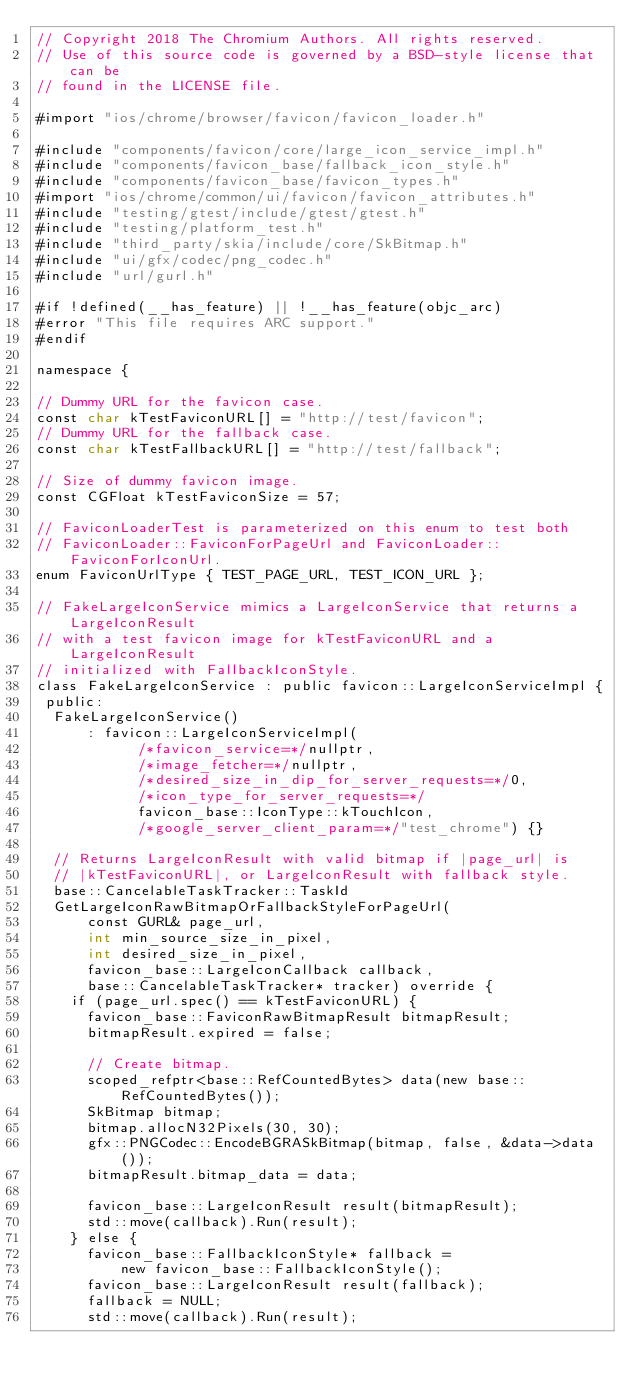<code> <loc_0><loc_0><loc_500><loc_500><_ObjectiveC_>// Copyright 2018 The Chromium Authors. All rights reserved.
// Use of this source code is governed by a BSD-style license that can be
// found in the LICENSE file.

#import "ios/chrome/browser/favicon/favicon_loader.h"

#include "components/favicon/core/large_icon_service_impl.h"
#include "components/favicon_base/fallback_icon_style.h"
#include "components/favicon_base/favicon_types.h"
#import "ios/chrome/common/ui/favicon/favicon_attributes.h"
#include "testing/gtest/include/gtest/gtest.h"
#include "testing/platform_test.h"
#include "third_party/skia/include/core/SkBitmap.h"
#include "ui/gfx/codec/png_codec.h"
#include "url/gurl.h"

#if !defined(__has_feature) || !__has_feature(objc_arc)
#error "This file requires ARC support."
#endif

namespace {

// Dummy URL for the favicon case.
const char kTestFaviconURL[] = "http://test/favicon";
// Dummy URL for the fallback case.
const char kTestFallbackURL[] = "http://test/fallback";

// Size of dummy favicon image.
const CGFloat kTestFaviconSize = 57;

// FaviconLoaderTest is parameterized on this enum to test both
// FaviconLoader::FaviconForPageUrl and FaviconLoader::FaviconForIconUrl.
enum FaviconUrlType { TEST_PAGE_URL, TEST_ICON_URL };

// FakeLargeIconService mimics a LargeIconService that returns a LargeIconResult
// with a test favicon image for kTestFaviconURL and a LargeIconResult
// initialized with FallbackIconStyle.
class FakeLargeIconService : public favicon::LargeIconServiceImpl {
 public:
  FakeLargeIconService()
      : favicon::LargeIconServiceImpl(
            /*favicon_service=*/nullptr,
            /*image_fetcher=*/nullptr,
            /*desired_size_in_dip_for_server_requests=*/0,
            /*icon_type_for_server_requests=*/
            favicon_base::IconType::kTouchIcon,
            /*google_server_client_param=*/"test_chrome") {}

  // Returns LargeIconResult with valid bitmap if |page_url| is
  // |kTestFaviconURL|, or LargeIconResult with fallback style.
  base::CancelableTaskTracker::TaskId
  GetLargeIconRawBitmapOrFallbackStyleForPageUrl(
      const GURL& page_url,
      int min_source_size_in_pixel,
      int desired_size_in_pixel,
      favicon_base::LargeIconCallback callback,
      base::CancelableTaskTracker* tracker) override {
    if (page_url.spec() == kTestFaviconURL) {
      favicon_base::FaviconRawBitmapResult bitmapResult;
      bitmapResult.expired = false;

      // Create bitmap.
      scoped_refptr<base::RefCountedBytes> data(new base::RefCountedBytes());
      SkBitmap bitmap;
      bitmap.allocN32Pixels(30, 30);
      gfx::PNGCodec::EncodeBGRASkBitmap(bitmap, false, &data->data());
      bitmapResult.bitmap_data = data;

      favicon_base::LargeIconResult result(bitmapResult);
      std::move(callback).Run(result);
    } else {
      favicon_base::FallbackIconStyle* fallback =
          new favicon_base::FallbackIconStyle();
      favicon_base::LargeIconResult result(fallback);
      fallback = NULL;
      std::move(callback).Run(result);</code> 